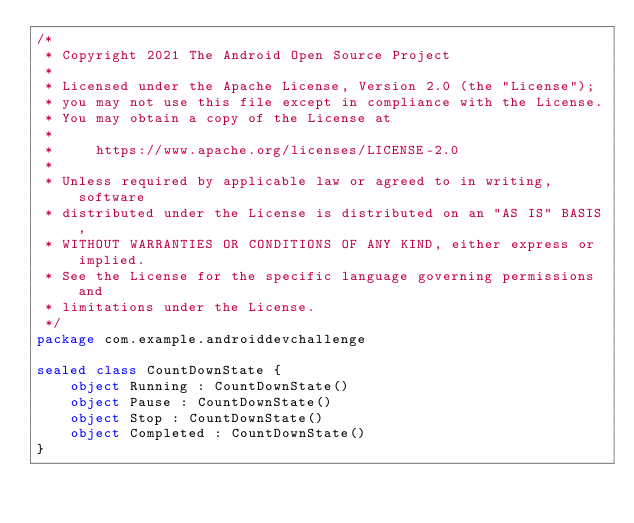<code> <loc_0><loc_0><loc_500><loc_500><_Kotlin_>/*
 * Copyright 2021 The Android Open Source Project
 *
 * Licensed under the Apache License, Version 2.0 (the "License");
 * you may not use this file except in compliance with the License.
 * You may obtain a copy of the License at
 *
 *     https://www.apache.org/licenses/LICENSE-2.0
 *
 * Unless required by applicable law or agreed to in writing, software
 * distributed under the License is distributed on an "AS IS" BASIS,
 * WITHOUT WARRANTIES OR CONDITIONS OF ANY KIND, either express or implied.
 * See the License for the specific language governing permissions and
 * limitations under the License.
 */
package com.example.androiddevchallenge

sealed class CountDownState {
    object Running : CountDownState()
    object Pause : CountDownState()
    object Stop : CountDownState()
    object Completed : CountDownState()
}
</code> 